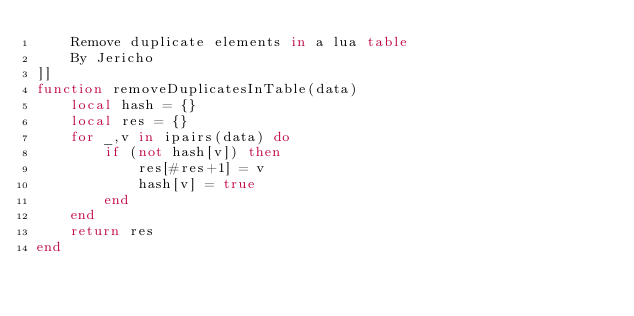<code> <loc_0><loc_0><loc_500><loc_500><_Lua_>	Remove duplicate elements in a lua table
	By Jericho
]]
function removeDuplicatesInTable(data) 
    local hash = {}
    local res = {}
    for _,v in ipairs(data) do
        if (not hash[v]) then
            res[#res+1] = v
            hash[v] = true
        end
    end
    return res
end</code> 